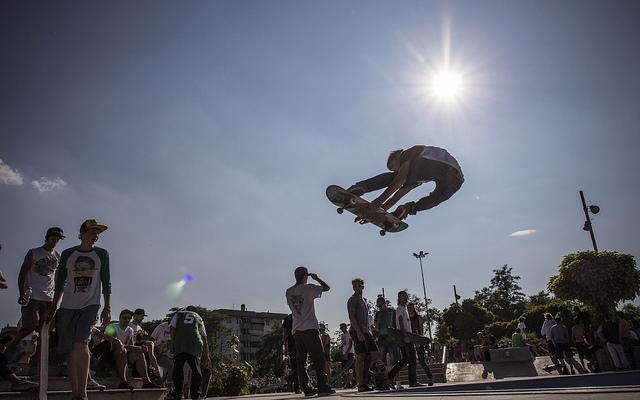How many people can be seen?
Give a very brief answer. 9. 